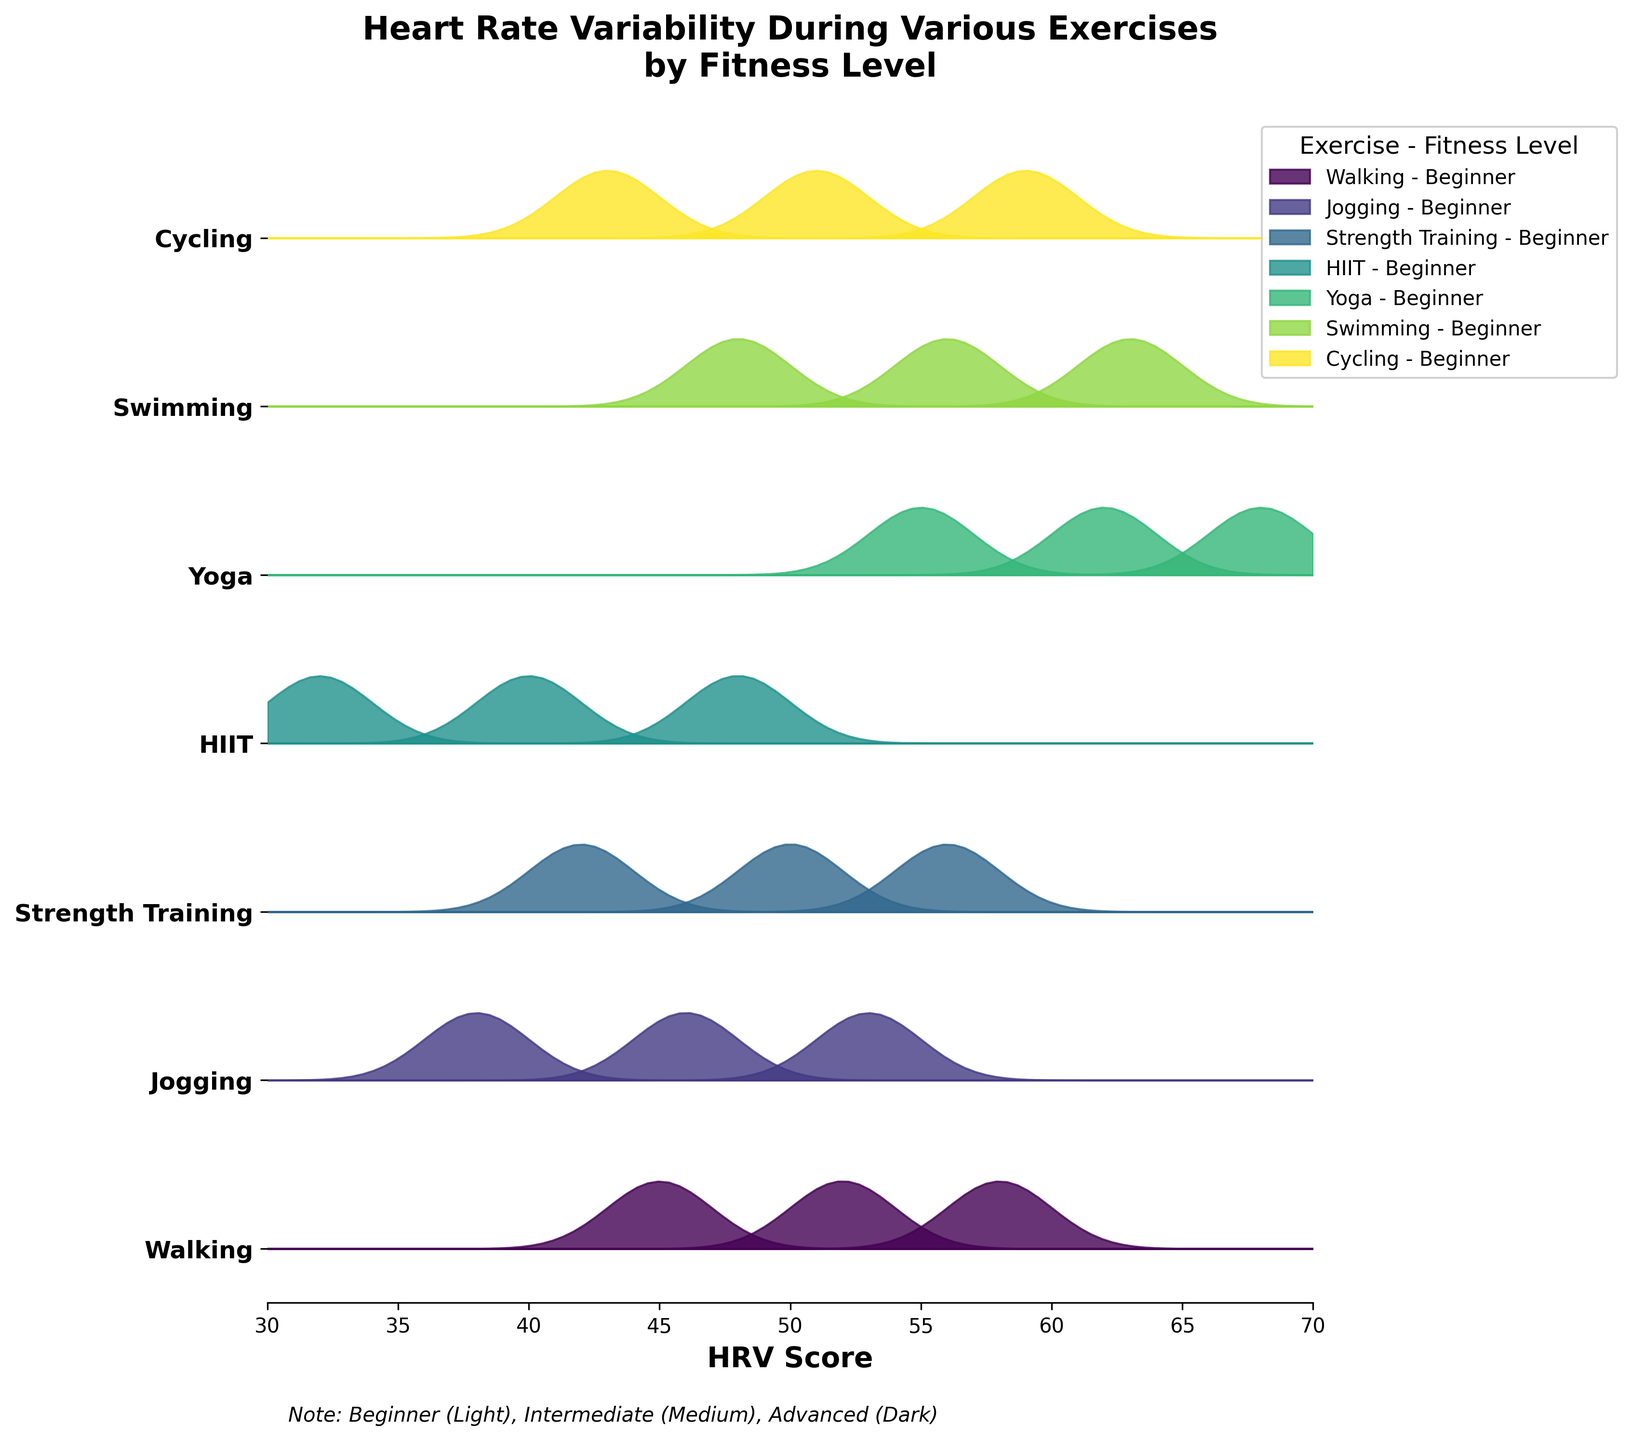What's the title of the figure? The title is written at the top of the figure and provides context about the data being visualized. The title says what's being compared and how.
Answer: Heart Rate Variability During Various Exercises by Fitness Level What is the range of HRV scores shown on the x-axis? The x-axis shows the HRV scores. From careful observation, we see that it spans from a minimum value to a maximum value.
Answer: 30 to 70 Which exercise shows the highest HRV score for an advanced fitness level? Observing the uppermost filled region in each group for the advanced fitness level will show the highest HRV. The tallest peak in the exercise groups indicates the highest HRV score.
Answer: Yoga How much higher is the HRV score for advanced HIIT compared to beginner HIIT? Find the HRV scores for advanced HIIT and beginner HIIT and subtract the beginner's value from the advanced's value. Advanced HIIT HRV is 48, and beginner HIIT HRV is 32. The difference is 48 - 32.
Answer: 16 Which exercises have a higher HRV score for beginners compared to intermediate strength training? Compare the HRV scores of beginners in each exercise with the HRV score of intermediate strength training. Intermediate strength training HRV is 50. Find exercises where the beginner's HRV is greater than 50.
Answer: Yoga, Swimming Which fitness level for swimming has a similar HRV score to advanced cycling? Look at the HRV score for advanced cycling, which is 59, and find a fitness level in swimming that has a similar score. Intermediate swimming has an HRV score close to this value.
Answer: Intermediate What type of exercise shows the lowest overall HRV score for any fitness level? By examining the lowest regions of each distribution, we see that HIIT shows the lowest overall HRV score for beginners, which is the smallest peak overall.
Answer: HIIT How do the HRV scores change from beginner to advanced for strength training? Examine the peaks for strength training for beginner, intermediate, and advanced fitness levels, and note the HRV scores at these points. The HRV scores increase from 42 to 50 to 56 respectively.
Answer: Increase 